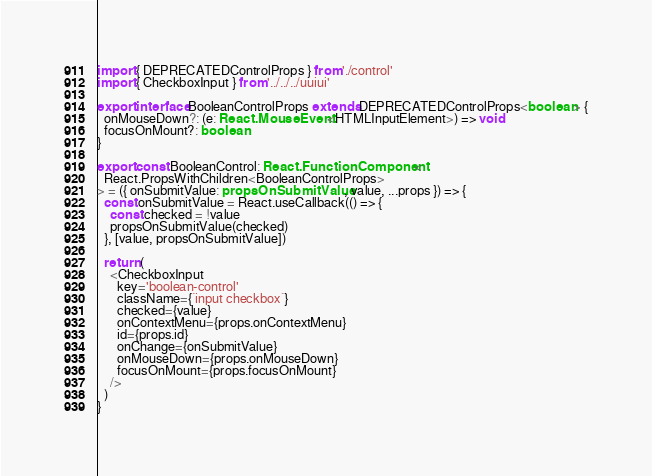Convert code to text. <code><loc_0><loc_0><loc_500><loc_500><_TypeScript_>import { DEPRECATEDControlProps } from './control'
import { CheckboxInput } from '../../../uuiui'

export interface BooleanControlProps extends DEPRECATEDControlProps<boolean> {
  onMouseDown?: (e: React.MouseEvent<HTMLInputElement>) => void
  focusOnMount?: boolean
}

export const BooleanControl: React.FunctionComponent<
  React.PropsWithChildren<BooleanControlProps>
> = ({ onSubmitValue: propsOnSubmitValue, value, ...props }) => {
  const onSubmitValue = React.useCallback(() => {
    const checked = !value
    propsOnSubmitValue(checked)
  }, [value, propsOnSubmitValue])

  return (
    <CheckboxInput
      key='boolean-control'
      className={`input checkbox`}
      checked={value}
      onContextMenu={props.onContextMenu}
      id={props.id}
      onChange={onSubmitValue}
      onMouseDown={props.onMouseDown}
      focusOnMount={props.focusOnMount}
    />
  )
}
</code> 